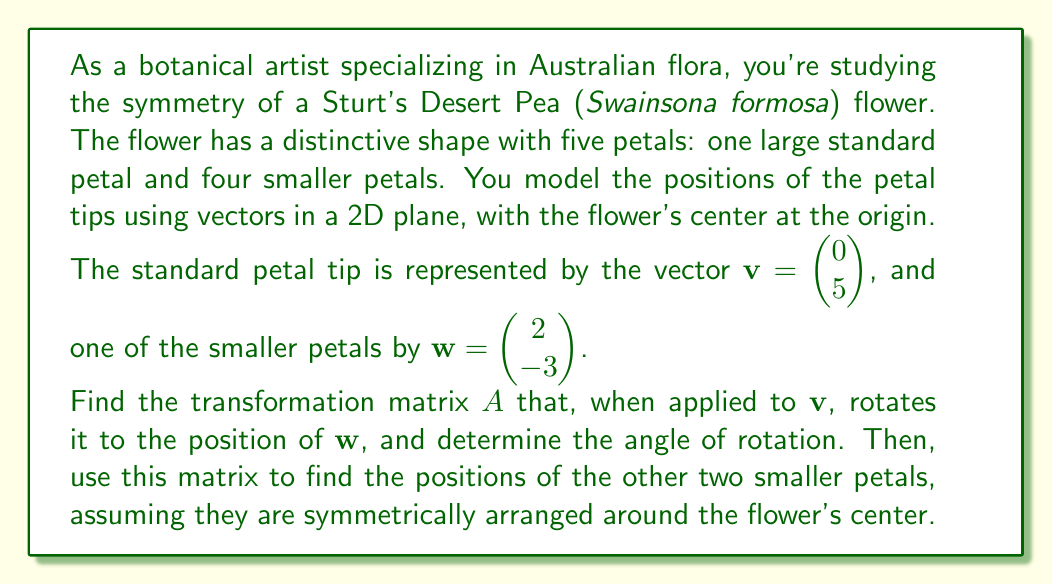Provide a solution to this math problem. Let's approach this step-by-step:

1) To find the transformation matrix $A$ that rotates $\mathbf{v}$ to $\mathbf{w}$, we need to use the rotation matrix:

   $$A = \begin{pmatrix} \cos\theta & -\sin\theta \\ \sin\theta & \cos\theta \end{pmatrix}$$

   where $\theta$ is the angle of rotation.

2) We know that $A\mathbf{v} = \mathbf{w}$, so:

   $$\begin{pmatrix} \cos\theta & -\sin\theta \\ \sin\theta & \cos\theta \end{pmatrix} \begin{pmatrix} 0 \\ 5 \end{pmatrix} = \begin{pmatrix} 2 \\ -3 \end{pmatrix}$$

3) This gives us two equations:
   
   $-5\sin\theta = 2$
   $5\cos\theta = -3$

4) Dividing these equations, we get:

   $\tan\theta = -\frac{2}{3}$

5) Taking the arctangent of both sides:

   $\theta = \arctan(-\frac{2}{3}) \approx -0.5880$ radians or $-33.69°$

6) Now we can find $\sin\theta$ and $\cos\theta$:

   $\sin\theta = -\frac{2}{5}$, $\cos\theta = -\frac{3}{5}$

7) Therefore, the transformation matrix $A$ is:

   $$A = \begin{pmatrix} -\frac{3}{5} & \frac{2}{5} \\ -\frac{2}{5} & -\frac{3}{5} \end{pmatrix}$$

8) To find the positions of the other two smaller petals, we need to apply $A$ twice more to $\mathbf{w}$:

   For the second petal: $A\mathbf{w} = \begin{pmatrix} -\frac{3}{5} & \frac{2}{5} \\ -\frac{2}{5} & -\frac{3}{5} \end{pmatrix} \begin{pmatrix} 2 \\ -3 \end{pmatrix} = \begin{pmatrix} -3 \\ -2 \end{pmatrix}$

   For the third petal: $A(A\mathbf{w}) = \begin{pmatrix} -\frac{3}{5} & \frac{2}{5} \\ -\frac{2}{5} & -\frac{3}{5} \end{pmatrix} \begin{pmatrix} -3 \\ -2 \end{pmatrix} = \begin{pmatrix} -2 \\ 3 \end{pmatrix}$
Answer: The transformation matrix $A$ is $$\begin{pmatrix} -\frac{3}{5} & \frac{2}{5} \\ -\frac{2}{5} & -\frac{3}{5} \end{pmatrix}$$
The angle of rotation is approximately $-33.69°$.
The positions of the other two smaller petals are $\begin{pmatrix} -3 \\ -2 \end{pmatrix}$ and $\begin{pmatrix} -2 \\ 3 \end{pmatrix}$. 